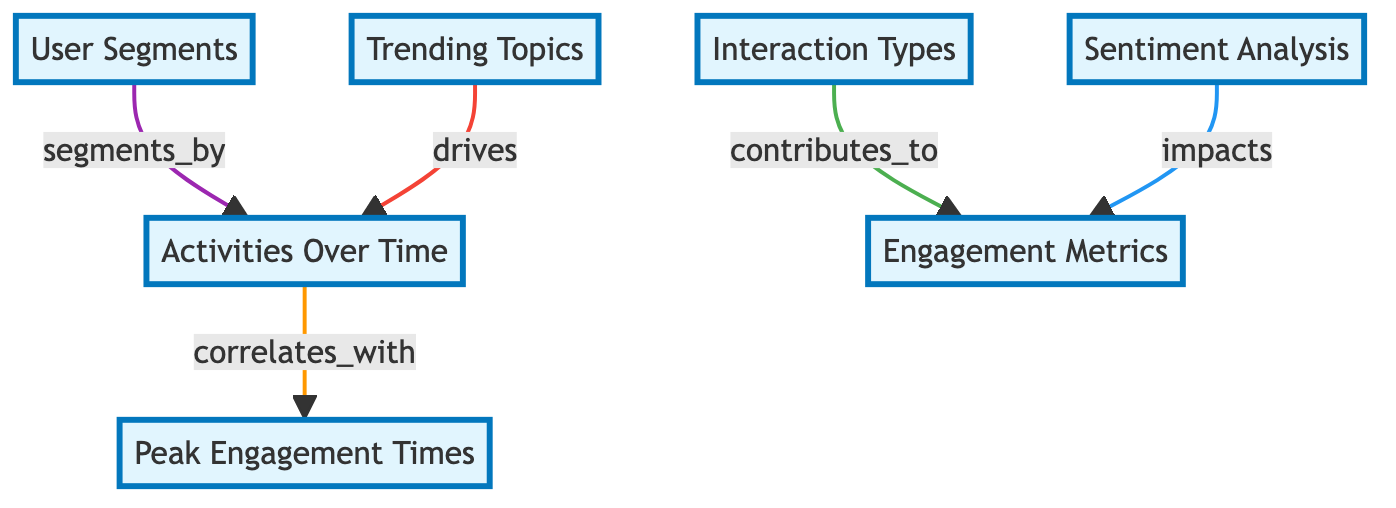What key activity is illustrated in the diagram? The diagram highlights "Activities Over Time" as the central node, indicating that it represents the primary focus of user engagement analysis.
Answer: Activities Over Time How many main components are represented in the diagram? The diagram has a total of seven main components including all the nodes (Activities Over Time, Peak Engagement Times, Interaction Types, Engagement Metrics, User Segments, Trending Topics, and Sentiment Analysis).
Answer: Seven What does "Interaction Types" contribute to in the diagram? The diagram shows that "Interaction Types" contributes to "Engagement Metrics," indicating a direct relationship between these two components.
Answer: Engagement Metrics Which component drives "Activities Over Time"? According to the flow in the diagram, "Trending Topics" is identified as the driving force behind "Activities Over Time," implying its significant impact on user engagement.
Answer: Trending Topics How are "User Segments" related to "Activities Over Time"? The diagram indicates that "User Segments" segments by "Activities Over Time," which establishes a direct link between these two components.
Answer: Segments by What is the relationship between "Sentiment Analysis" and "Engagement Metrics"? The diagram illustrates that "Sentiment Analysis" impacts "Engagement Metrics," suggesting that user sentiment plays a role in determining engagement levels.
Answer: Impacts Which node is correlated with "Peak Engagement Times"? The flow diagram shows that "Activities Over Time" correlates with "Peak Engagement Times," meaning that understanding user activities can help identify when engagement peaks occur.
Answer: Activities Over Time What color indicates the relationships in the diagram? The diagram uses different colors to distinguish relationships; for example, the orange stroke represents one of the highlighted relationships in the flow between nodes.
Answer: Orange 